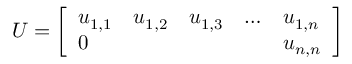Convert formula to latex. <formula><loc_0><loc_0><loc_500><loc_500>U = { \left [ \begin{array} { l l l l l } { u _ { 1 , 1 } } & { u _ { 1 , 2 } } & { u _ { 1 , 3 } } & { \dots } & { u _ { 1 , n } } \\ { 0 } & { u _ { n , n } } \end{array} \right ] }</formula> 